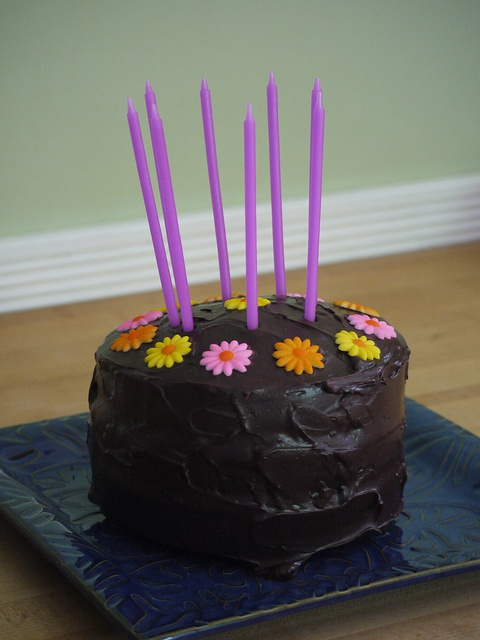Describe the objects in this image and their specific colors. I can see a cake in gray, black, and darkgreen tones in this image. 